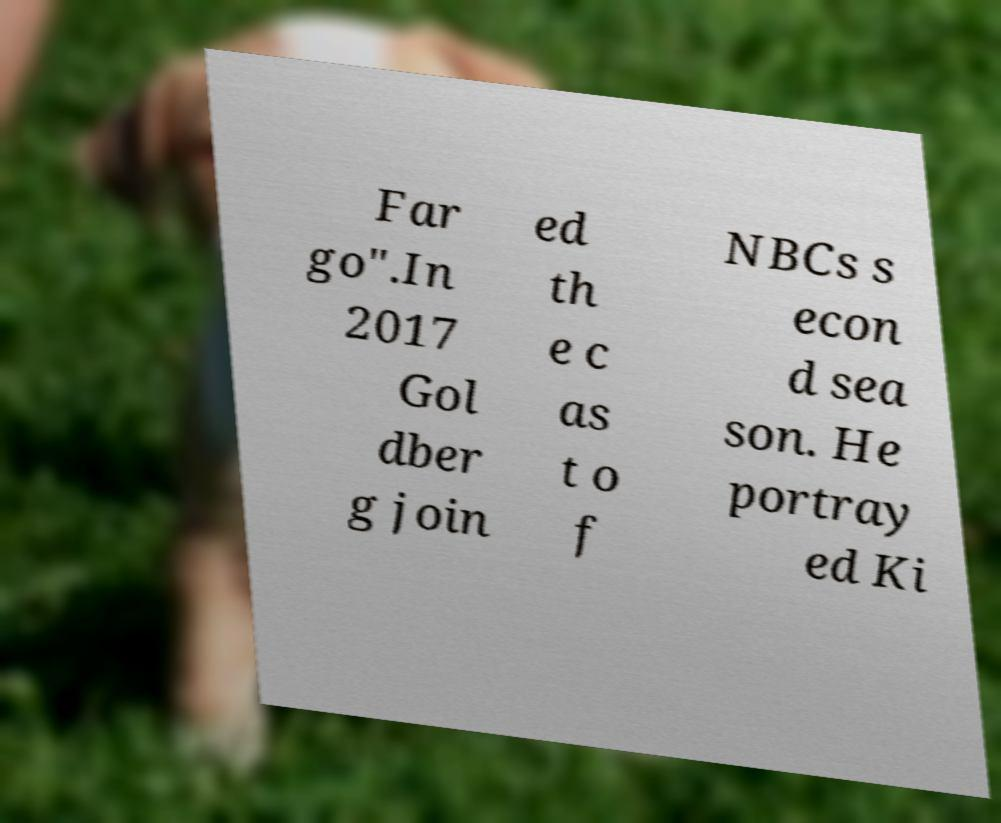Please identify and transcribe the text found in this image. Far go".In 2017 Gol dber g join ed th e c as t o f NBCs s econ d sea son. He portray ed Ki 